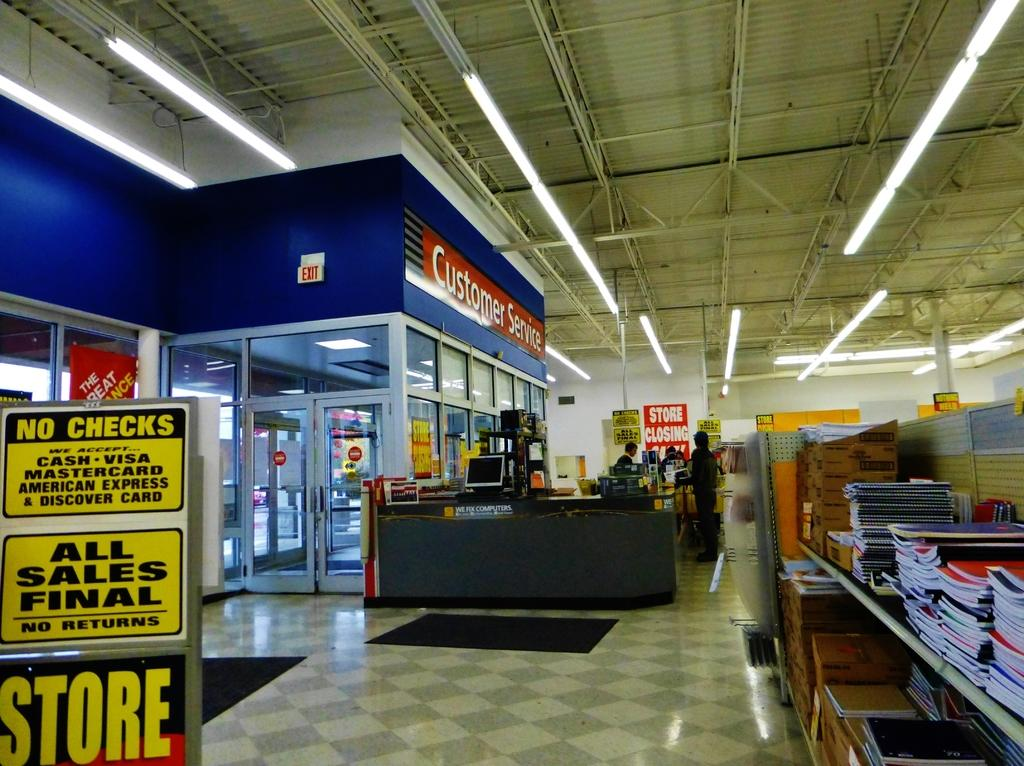Provide a one-sentence caption for the provided image. Store that contains books and customer service that do not accept checks. 